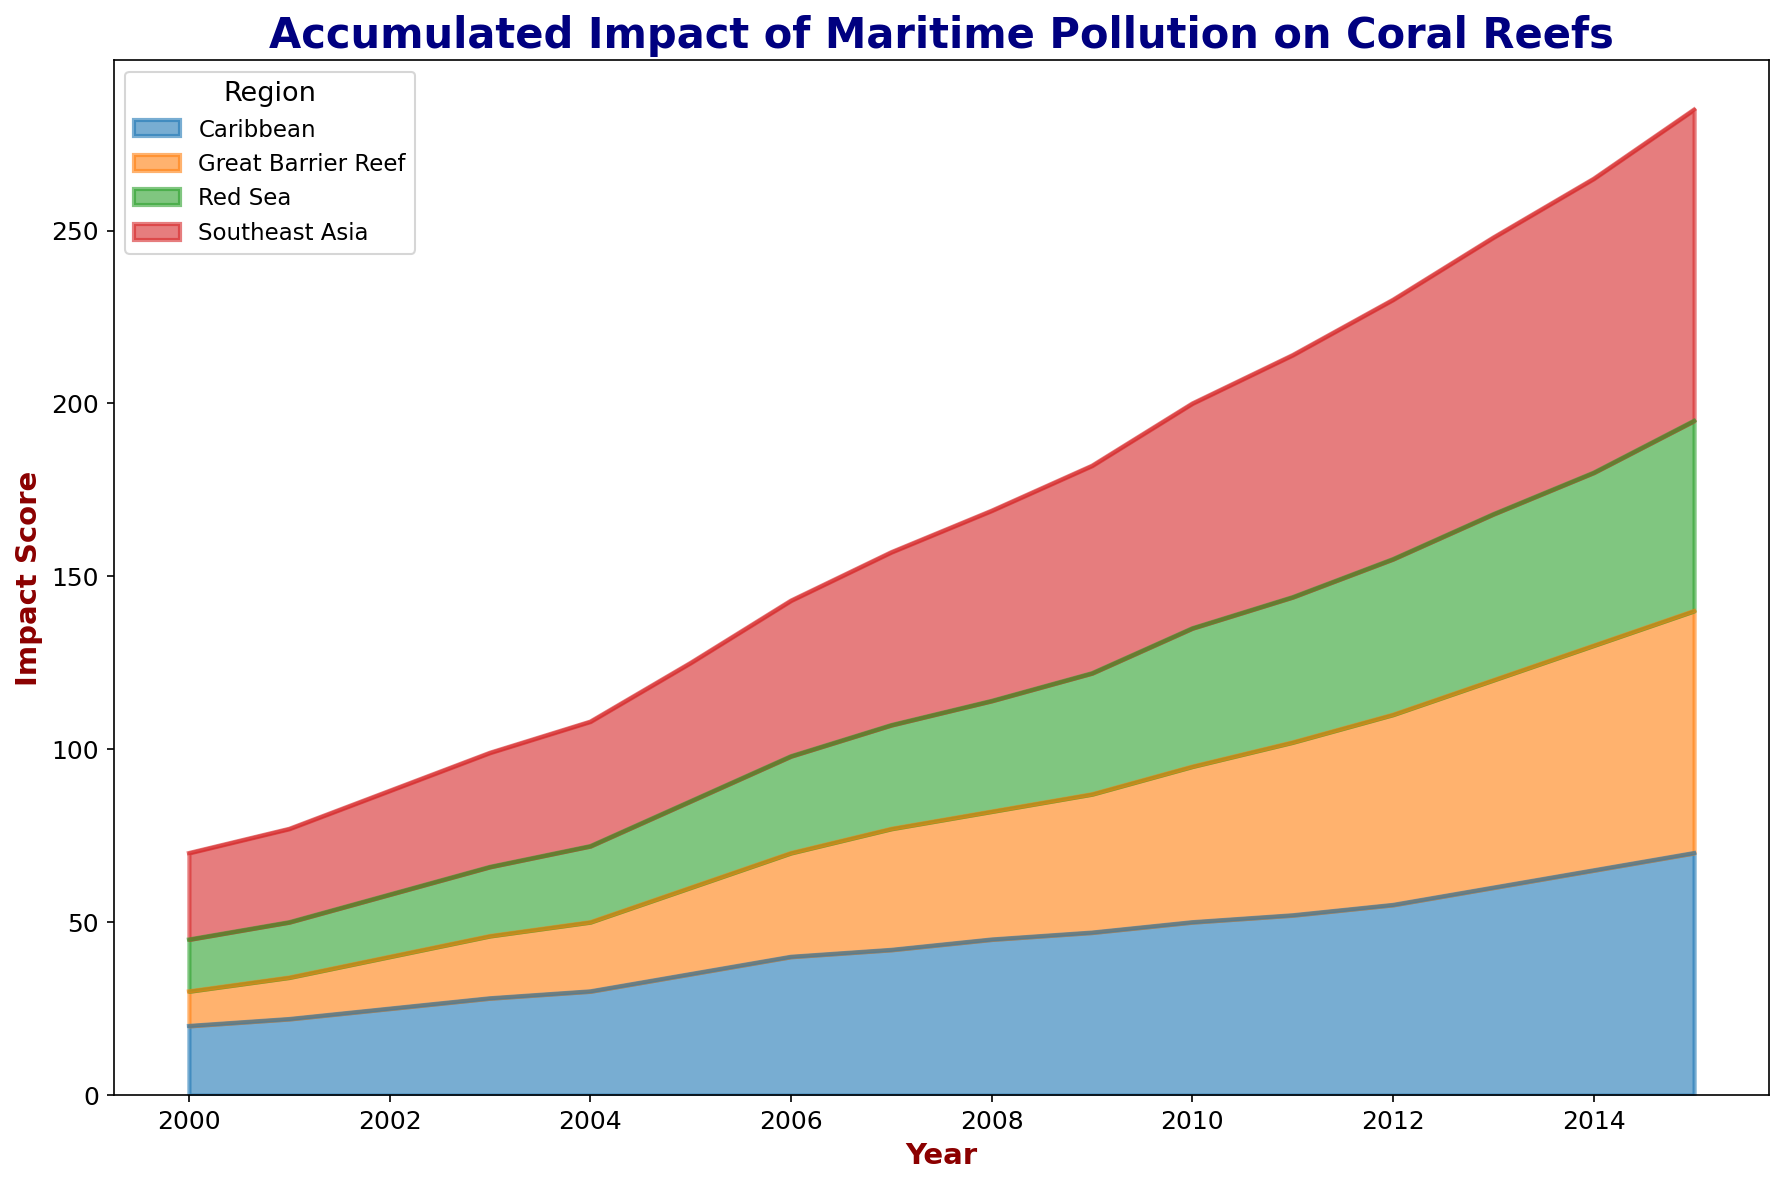What's the region with the highest accumulated impact score in 2015? Look at the plot and identify the region with the highest point in 2015. Southeast Asia reaches a score of 90, which is higher than the other regions.
Answer: Southeast Asia Which year experienced the sharpest increase in impact score in the Caribbean? Analyze the plot for the Caribbean region and look for the largest vertical gap between consecutive years. From 2005 to 2006, the impact score jumped from 35 to 40, which is the sharpest increase.
Answer: 2005 to 2006 Compare the impact scores of the Southeast Asia and the Great Barrier Reef in 2010. In 2010, the impact score of Southeast Asia is 65, and the impact score of the Great Barrier Reef is 45.
Answer: Southeast Asia: 65, Great Barrier Reef: 45 Which region showed the slowest growth in impact score over the observed period? By examining the gradients of the area plots, the Red Sea shows the slowest overall increase in impact score, indicated by its more gradual slope compared to other regions.
Answer: Red Sea Calculate the total impact score of the Great Barrier Reef and the Caribbean combined in the year 2012. Find the impact scores for 2012: Great Barrier Reef (55) and Caribbean (55). Sum these two values: 55 + 55 = 110.
Answer: 110 What visual feature indicates the region with the largest cumulative impact score? The region with the largest cumulative impact score will have the widest and tallest area in the plot. Southeast Asia, with a significantly wide and tall area by 2015, indicates the largest cumulative impact.
Answer: Southeast Asia Between which years did the Red Sea experience the most gradual increase in impact score? Assess the slope of the plot for the Red Sea. The most gradual increase occurs between 2001 and 2005, where the score barely changes.
Answer: 2001 to 2005 Estimate the average yearly increase in impact score for Southeast Asia between 2000 and 2015. Subtract the 2000 impact score from the 2015 impact score for Southeast Asia: 90 - 25 = 65. Divide by the number of years: 65/15 ≈ 4.33.
Answer: Approximately 4.33 Identify the region and year where the impact score crossed 50 for the first time. Scan the plot for each region and year to find the first instance where the score reaches or exceeds 50. The Great Barrier Reef reaches 50 in 2011.
Answer: Great Barrier Reef, 2011 What's the difference in impact scores between the Caribbean and the Red Sea in 2008? In 2008, the impact score for the Caribbean is 45 and for the Red Sea is 32. The difference is 45 - 32 = 13.
Answer: 13 